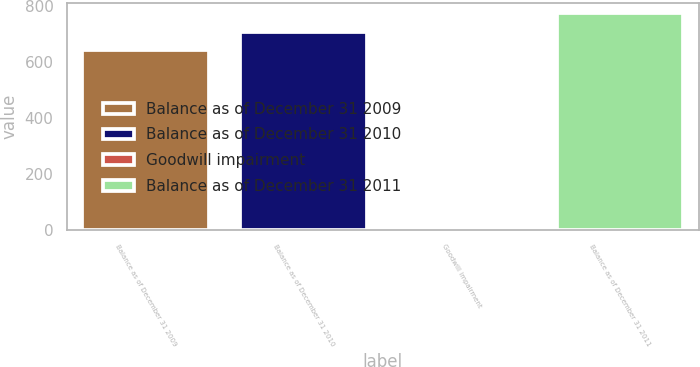Convert chart to OTSL. <chart><loc_0><loc_0><loc_500><loc_500><bar_chart><fcel>Balance as of December 31 2009<fcel>Balance as of December 31 2010<fcel>Goodwill impairment<fcel>Balance as of December 31 2011<nl><fcel>646<fcel>710.48<fcel>1.21<fcel>774.96<nl></chart> 